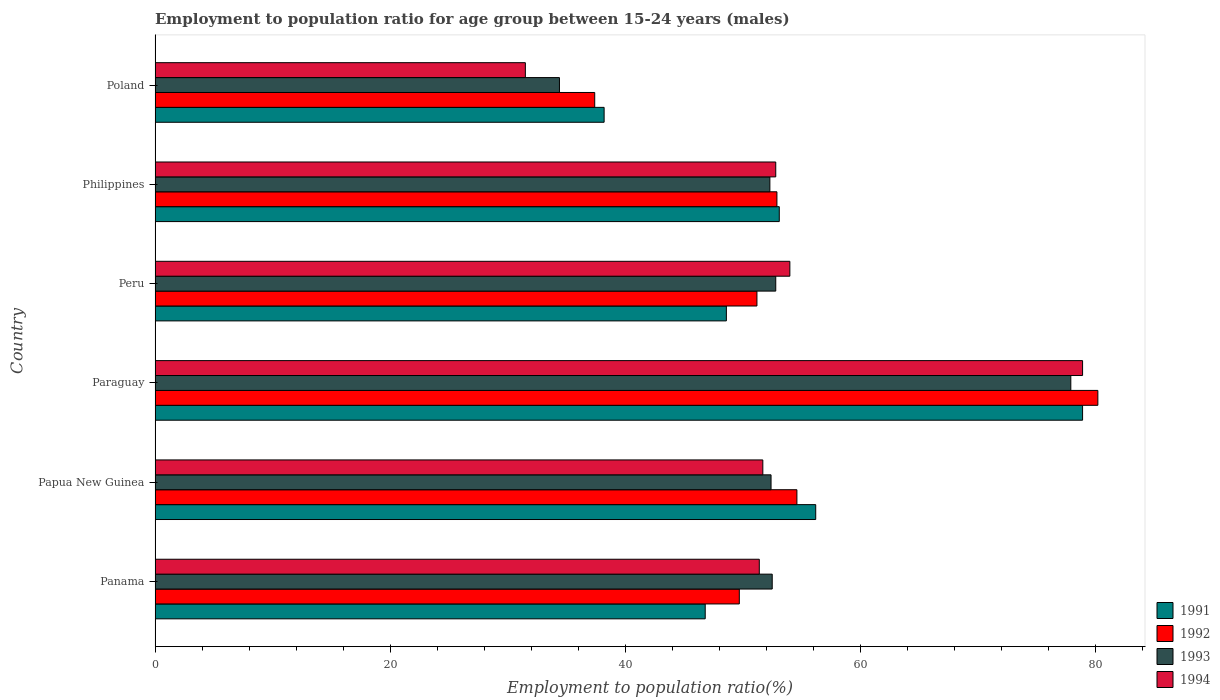How many different coloured bars are there?
Your answer should be compact. 4. How many groups of bars are there?
Provide a short and direct response. 6. Are the number of bars on each tick of the Y-axis equal?
Keep it short and to the point. Yes. What is the label of the 4th group of bars from the top?
Your response must be concise. Paraguay. What is the employment to population ratio in 1993 in Paraguay?
Ensure brevity in your answer.  77.9. Across all countries, what is the maximum employment to population ratio in 1992?
Ensure brevity in your answer.  80.2. Across all countries, what is the minimum employment to population ratio in 1993?
Ensure brevity in your answer.  34.4. In which country was the employment to population ratio in 1994 maximum?
Give a very brief answer. Paraguay. In which country was the employment to population ratio in 1994 minimum?
Ensure brevity in your answer.  Poland. What is the total employment to population ratio in 1991 in the graph?
Your answer should be very brief. 321.8. What is the difference between the employment to population ratio in 1993 in Papua New Guinea and that in Paraguay?
Your answer should be very brief. -25.5. What is the difference between the employment to population ratio in 1992 in Papua New Guinea and the employment to population ratio in 1991 in Panama?
Your answer should be very brief. 7.8. What is the average employment to population ratio in 1993 per country?
Your answer should be compact. 53.72. What is the difference between the employment to population ratio in 1993 and employment to population ratio in 1994 in Panama?
Make the answer very short. 1.1. What is the ratio of the employment to population ratio in 1993 in Panama to that in Poland?
Your answer should be compact. 1.53. Is the employment to population ratio in 1992 in Panama less than that in Papua New Guinea?
Give a very brief answer. Yes. Is the difference between the employment to population ratio in 1993 in Paraguay and Peru greater than the difference between the employment to population ratio in 1994 in Paraguay and Peru?
Your answer should be compact. Yes. What is the difference between the highest and the second highest employment to population ratio in 1992?
Give a very brief answer. 25.6. What is the difference between the highest and the lowest employment to population ratio in 1993?
Provide a succinct answer. 43.5. Is the sum of the employment to population ratio in 1991 in Panama and Philippines greater than the maximum employment to population ratio in 1993 across all countries?
Provide a short and direct response. Yes. Is it the case that in every country, the sum of the employment to population ratio in 1993 and employment to population ratio in 1992 is greater than the sum of employment to population ratio in 1991 and employment to population ratio in 1994?
Ensure brevity in your answer.  No. What does the 1st bar from the bottom in Peru represents?
Your response must be concise. 1991. How many countries are there in the graph?
Offer a terse response. 6. Does the graph contain any zero values?
Your answer should be very brief. No. Does the graph contain grids?
Your answer should be compact. No. Where does the legend appear in the graph?
Ensure brevity in your answer.  Bottom right. What is the title of the graph?
Your answer should be very brief. Employment to population ratio for age group between 15-24 years (males). What is the label or title of the X-axis?
Keep it short and to the point. Employment to population ratio(%). What is the label or title of the Y-axis?
Offer a very short reply. Country. What is the Employment to population ratio(%) of 1991 in Panama?
Offer a terse response. 46.8. What is the Employment to population ratio(%) of 1992 in Panama?
Keep it short and to the point. 49.7. What is the Employment to population ratio(%) of 1993 in Panama?
Ensure brevity in your answer.  52.5. What is the Employment to population ratio(%) in 1994 in Panama?
Provide a short and direct response. 51.4. What is the Employment to population ratio(%) in 1991 in Papua New Guinea?
Your response must be concise. 56.2. What is the Employment to population ratio(%) in 1992 in Papua New Guinea?
Offer a terse response. 54.6. What is the Employment to population ratio(%) in 1993 in Papua New Guinea?
Offer a very short reply. 52.4. What is the Employment to population ratio(%) in 1994 in Papua New Guinea?
Your response must be concise. 51.7. What is the Employment to population ratio(%) of 1991 in Paraguay?
Your answer should be compact. 78.9. What is the Employment to population ratio(%) of 1992 in Paraguay?
Ensure brevity in your answer.  80.2. What is the Employment to population ratio(%) in 1993 in Paraguay?
Keep it short and to the point. 77.9. What is the Employment to population ratio(%) of 1994 in Paraguay?
Your answer should be compact. 78.9. What is the Employment to population ratio(%) in 1991 in Peru?
Your answer should be compact. 48.6. What is the Employment to population ratio(%) of 1992 in Peru?
Offer a terse response. 51.2. What is the Employment to population ratio(%) in 1993 in Peru?
Your answer should be compact. 52.8. What is the Employment to population ratio(%) in 1994 in Peru?
Give a very brief answer. 54. What is the Employment to population ratio(%) of 1991 in Philippines?
Offer a very short reply. 53.1. What is the Employment to population ratio(%) in 1992 in Philippines?
Keep it short and to the point. 52.9. What is the Employment to population ratio(%) in 1993 in Philippines?
Keep it short and to the point. 52.3. What is the Employment to population ratio(%) of 1994 in Philippines?
Provide a short and direct response. 52.8. What is the Employment to population ratio(%) in 1991 in Poland?
Provide a short and direct response. 38.2. What is the Employment to population ratio(%) in 1992 in Poland?
Provide a succinct answer. 37.4. What is the Employment to population ratio(%) in 1993 in Poland?
Your response must be concise. 34.4. What is the Employment to population ratio(%) of 1994 in Poland?
Offer a very short reply. 31.5. Across all countries, what is the maximum Employment to population ratio(%) of 1991?
Provide a succinct answer. 78.9. Across all countries, what is the maximum Employment to population ratio(%) in 1992?
Keep it short and to the point. 80.2. Across all countries, what is the maximum Employment to population ratio(%) of 1993?
Keep it short and to the point. 77.9. Across all countries, what is the maximum Employment to population ratio(%) of 1994?
Your response must be concise. 78.9. Across all countries, what is the minimum Employment to population ratio(%) of 1991?
Your answer should be very brief. 38.2. Across all countries, what is the minimum Employment to population ratio(%) of 1992?
Provide a succinct answer. 37.4. Across all countries, what is the minimum Employment to population ratio(%) in 1993?
Provide a short and direct response. 34.4. Across all countries, what is the minimum Employment to population ratio(%) of 1994?
Your response must be concise. 31.5. What is the total Employment to population ratio(%) in 1991 in the graph?
Give a very brief answer. 321.8. What is the total Employment to population ratio(%) of 1992 in the graph?
Your response must be concise. 326. What is the total Employment to population ratio(%) of 1993 in the graph?
Keep it short and to the point. 322.3. What is the total Employment to population ratio(%) in 1994 in the graph?
Your response must be concise. 320.3. What is the difference between the Employment to population ratio(%) of 1992 in Panama and that in Papua New Guinea?
Provide a succinct answer. -4.9. What is the difference between the Employment to population ratio(%) of 1993 in Panama and that in Papua New Guinea?
Offer a very short reply. 0.1. What is the difference between the Employment to population ratio(%) in 1994 in Panama and that in Papua New Guinea?
Your answer should be compact. -0.3. What is the difference between the Employment to population ratio(%) in 1991 in Panama and that in Paraguay?
Make the answer very short. -32.1. What is the difference between the Employment to population ratio(%) of 1992 in Panama and that in Paraguay?
Your response must be concise. -30.5. What is the difference between the Employment to population ratio(%) of 1993 in Panama and that in Paraguay?
Give a very brief answer. -25.4. What is the difference between the Employment to population ratio(%) in 1994 in Panama and that in Paraguay?
Provide a short and direct response. -27.5. What is the difference between the Employment to population ratio(%) in 1992 in Panama and that in Peru?
Offer a terse response. -1.5. What is the difference between the Employment to population ratio(%) of 1991 in Panama and that in Philippines?
Provide a succinct answer. -6.3. What is the difference between the Employment to population ratio(%) in 1992 in Panama and that in Philippines?
Ensure brevity in your answer.  -3.2. What is the difference between the Employment to population ratio(%) of 1993 in Panama and that in Philippines?
Give a very brief answer. 0.2. What is the difference between the Employment to population ratio(%) of 1991 in Panama and that in Poland?
Your answer should be very brief. 8.6. What is the difference between the Employment to population ratio(%) of 1994 in Panama and that in Poland?
Provide a short and direct response. 19.9. What is the difference between the Employment to population ratio(%) of 1991 in Papua New Guinea and that in Paraguay?
Ensure brevity in your answer.  -22.7. What is the difference between the Employment to population ratio(%) of 1992 in Papua New Guinea and that in Paraguay?
Make the answer very short. -25.6. What is the difference between the Employment to population ratio(%) of 1993 in Papua New Guinea and that in Paraguay?
Your answer should be compact. -25.5. What is the difference between the Employment to population ratio(%) in 1994 in Papua New Guinea and that in Paraguay?
Give a very brief answer. -27.2. What is the difference between the Employment to population ratio(%) of 1994 in Papua New Guinea and that in Peru?
Give a very brief answer. -2.3. What is the difference between the Employment to population ratio(%) of 1991 in Papua New Guinea and that in Philippines?
Your answer should be very brief. 3.1. What is the difference between the Employment to population ratio(%) of 1993 in Papua New Guinea and that in Philippines?
Give a very brief answer. 0.1. What is the difference between the Employment to population ratio(%) of 1991 in Papua New Guinea and that in Poland?
Make the answer very short. 18. What is the difference between the Employment to population ratio(%) in 1992 in Papua New Guinea and that in Poland?
Provide a succinct answer. 17.2. What is the difference between the Employment to population ratio(%) of 1993 in Papua New Guinea and that in Poland?
Offer a very short reply. 18. What is the difference between the Employment to population ratio(%) in 1994 in Papua New Guinea and that in Poland?
Your answer should be very brief. 20.2. What is the difference between the Employment to population ratio(%) in 1991 in Paraguay and that in Peru?
Offer a very short reply. 30.3. What is the difference between the Employment to population ratio(%) in 1992 in Paraguay and that in Peru?
Ensure brevity in your answer.  29. What is the difference between the Employment to population ratio(%) of 1993 in Paraguay and that in Peru?
Offer a terse response. 25.1. What is the difference between the Employment to population ratio(%) of 1994 in Paraguay and that in Peru?
Provide a short and direct response. 24.9. What is the difference between the Employment to population ratio(%) in 1991 in Paraguay and that in Philippines?
Give a very brief answer. 25.8. What is the difference between the Employment to population ratio(%) in 1992 in Paraguay and that in Philippines?
Your answer should be very brief. 27.3. What is the difference between the Employment to population ratio(%) in 1993 in Paraguay and that in Philippines?
Your answer should be compact. 25.6. What is the difference between the Employment to population ratio(%) of 1994 in Paraguay and that in Philippines?
Offer a terse response. 26.1. What is the difference between the Employment to population ratio(%) of 1991 in Paraguay and that in Poland?
Your answer should be very brief. 40.7. What is the difference between the Employment to population ratio(%) of 1992 in Paraguay and that in Poland?
Make the answer very short. 42.8. What is the difference between the Employment to population ratio(%) of 1993 in Paraguay and that in Poland?
Ensure brevity in your answer.  43.5. What is the difference between the Employment to population ratio(%) of 1994 in Paraguay and that in Poland?
Your answer should be compact. 47.4. What is the difference between the Employment to population ratio(%) of 1992 in Peru and that in Philippines?
Offer a very short reply. -1.7. What is the difference between the Employment to population ratio(%) in 1991 in Peru and that in Poland?
Make the answer very short. 10.4. What is the difference between the Employment to population ratio(%) of 1992 in Philippines and that in Poland?
Provide a succinct answer. 15.5. What is the difference between the Employment to population ratio(%) of 1994 in Philippines and that in Poland?
Your answer should be very brief. 21.3. What is the difference between the Employment to population ratio(%) in 1992 in Panama and the Employment to population ratio(%) in 1993 in Papua New Guinea?
Keep it short and to the point. -2.7. What is the difference between the Employment to population ratio(%) in 1992 in Panama and the Employment to population ratio(%) in 1994 in Papua New Guinea?
Offer a terse response. -2. What is the difference between the Employment to population ratio(%) of 1993 in Panama and the Employment to population ratio(%) of 1994 in Papua New Guinea?
Offer a terse response. 0.8. What is the difference between the Employment to population ratio(%) of 1991 in Panama and the Employment to population ratio(%) of 1992 in Paraguay?
Give a very brief answer. -33.4. What is the difference between the Employment to population ratio(%) in 1991 in Panama and the Employment to population ratio(%) in 1993 in Paraguay?
Keep it short and to the point. -31.1. What is the difference between the Employment to population ratio(%) in 1991 in Panama and the Employment to population ratio(%) in 1994 in Paraguay?
Your answer should be compact. -32.1. What is the difference between the Employment to population ratio(%) of 1992 in Panama and the Employment to population ratio(%) of 1993 in Paraguay?
Ensure brevity in your answer.  -28.2. What is the difference between the Employment to population ratio(%) of 1992 in Panama and the Employment to population ratio(%) of 1994 in Paraguay?
Offer a very short reply. -29.2. What is the difference between the Employment to population ratio(%) of 1993 in Panama and the Employment to population ratio(%) of 1994 in Paraguay?
Provide a succinct answer. -26.4. What is the difference between the Employment to population ratio(%) of 1991 in Panama and the Employment to population ratio(%) of 1994 in Peru?
Offer a terse response. -7.2. What is the difference between the Employment to population ratio(%) in 1992 in Panama and the Employment to population ratio(%) in 1993 in Peru?
Provide a short and direct response. -3.1. What is the difference between the Employment to population ratio(%) of 1992 in Panama and the Employment to population ratio(%) of 1994 in Peru?
Your answer should be compact. -4.3. What is the difference between the Employment to population ratio(%) in 1993 in Panama and the Employment to population ratio(%) in 1994 in Peru?
Ensure brevity in your answer.  -1.5. What is the difference between the Employment to population ratio(%) in 1992 in Panama and the Employment to population ratio(%) in 1993 in Philippines?
Ensure brevity in your answer.  -2.6. What is the difference between the Employment to population ratio(%) in 1993 in Panama and the Employment to population ratio(%) in 1994 in Philippines?
Offer a very short reply. -0.3. What is the difference between the Employment to population ratio(%) of 1991 in Panama and the Employment to population ratio(%) of 1993 in Poland?
Keep it short and to the point. 12.4. What is the difference between the Employment to population ratio(%) in 1992 in Panama and the Employment to population ratio(%) in 1994 in Poland?
Provide a succinct answer. 18.2. What is the difference between the Employment to population ratio(%) of 1993 in Panama and the Employment to population ratio(%) of 1994 in Poland?
Your answer should be very brief. 21. What is the difference between the Employment to population ratio(%) of 1991 in Papua New Guinea and the Employment to population ratio(%) of 1993 in Paraguay?
Provide a short and direct response. -21.7. What is the difference between the Employment to population ratio(%) in 1991 in Papua New Guinea and the Employment to population ratio(%) in 1994 in Paraguay?
Offer a very short reply. -22.7. What is the difference between the Employment to population ratio(%) in 1992 in Papua New Guinea and the Employment to population ratio(%) in 1993 in Paraguay?
Give a very brief answer. -23.3. What is the difference between the Employment to population ratio(%) of 1992 in Papua New Guinea and the Employment to population ratio(%) of 1994 in Paraguay?
Offer a very short reply. -24.3. What is the difference between the Employment to population ratio(%) of 1993 in Papua New Guinea and the Employment to population ratio(%) of 1994 in Paraguay?
Your response must be concise. -26.5. What is the difference between the Employment to population ratio(%) of 1991 in Papua New Guinea and the Employment to population ratio(%) of 1992 in Peru?
Provide a short and direct response. 5. What is the difference between the Employment to population ratio(%) of 1991 in Papua New Guinea and the Employment to population ratio(%) of 1994 in Peru?
Your answer should be compact. 2.2. What is the difference between the Employment to population ratio(%) of 1992 in Papua New Guinea and the Employment to population ratio(%) of 1993 in Peru?
Make the answer very short. 1.8. What is the difference between the Employment to population ratio(%) in 1991 in Papua New Guinea and the Employment to population ratio(%) in 1993 in Poland?
Your answer should be very brief. 21.8. What is the difference between the Employment to population ratio(%) of 1991 in Papua New Guinea and the Employment to population ratio(%) of 1994 in Poland?
Your answer should be compact. 24.7. What is the difference between the Employment to population ratio(%) in 1992 in Papua New Guinea and the Employment to population ratio(%) in 1993 in Poland?
Keep it short and to the point. 20.2. What is the difference between the Employment to population ratio(%) of 1992 in Papua New Guinea and the Employment to population ratio(%) of 1994 in Poland?
Give a very brief answer. 23.1. What is the difference between the Employment to population ratio(%) in 1993 in Papua New Guinea and the Employment to population ratio(%) in 1994 in Poland?
Give a very brief answer. 20.9. What is the difference between the Employment to population ratio(%) of 1991 in Paraguay and the Employment to population ratio(%) of 1992 in Peru?
Your answer should be compact. 27.7. What is the difference between the Employment to population ratio(%) of 1991 in Paraguay and the Employment to population ratio(%) of 1993 in Peru?
Keep it short and to the point. 26.1. What is the difference between the Employment to population ratio(%) of 1991 in Paraguay and the Employment to population ratio(%) of 1994 in Peru?
Provide a short and direct response. 24.9. What is the difference between the Employment to population ratio(%) in 1992 in Paraguay and the Employment to population ratio(%) in 1993 in Peru?
Your answer should be very brief. 27.4. What is the difference between the Employment to population ratio(%) of 1992 in Paraguay and the Employment to population ratio(%) of 1994 in Peru?
Your answer should be compact. 26.2. What is the difference between the Employment to population ratio(%) in 1993 in Paraguay and the Employment to population ratio(%) in 1994 in Peru?
Offer a terse response. 23.9. What is the difference between the Employment to population ratio(%) of 1991 in Paraguay and the Employment to population ratio(%) of 1992 in Philippines?
Offer a very short reply. 26. What is the difference between the Employment to population ratio(%) of 1991 in Paraguay and the Employment to population ratio(%) of 1993 in Philippines?
Your response must be concise. 26.6. What is the difference between the Employment to population ratio(%) of 1991 in Paraguay and the Employment to population ratio(%) of 1994 in Philippines?
Offer a very short reply. 26.1. What is the difference between the Employment to population ratio(%) of 1992 in Paraguay and the Employment to population ratio(%) of 1993 in Philippines?
Offer a very short reply. 27.9. What is the difference between the Employment to population ratio(%) in 1992 in Paraguay and the Employment to population ratio(%) in 1994 in Philippines?
Provide a succinct answer. 27.4. What is the difference between the Employment to population ratio(%) of 1993 in Paraguay and the Employment to population ratio(%) of 1994 in Philippines?
Give a very brief answer. 25.1. What is the difference between the Employment to population ratio(%) in 1991 in Paraguay and the Employment to population ratio(%) in 1992 in Poland?
Ensure brevity in your answer.  41.5. What is the difference between the Employment to population ratio(%) in 1991 in Paraguay and the Employment to population ratio(%) in 1993 in Poland?
Provide a succinct answer. 44.5. What is the difference between the Employment to population ratio(%) of 1991 in Paraguay and the Employment to population ratio(%) of 1994 in Poland?
Provide a succinct answer. 47.4. What is the difference between the Employment to population ratio(%) in 1992 in Paraguay and the Employment to population ratio(%) in 1993 in Poland?
Offer a very short reply. 45.8. What is the difference between the Employment to population ratio(%) of 1992 in Paraguay and the Employment to population ratio(%) of 1994 in Poland?
Your answer should be very brief. 48.7. What is the difference between the Employment to population ratio(%) of 1993 in Paraguay and the Employment to population ratio(%) of 1994 in Poland?
Make the answer very short. 46.4. What is the difference between the Employment to population ratio(%) in 1991 in Peru and the Employment to population ratio(%) in 1992 in Philippines?
Offer a very short reply. -4.3. What is the difference between the Employment to population ratio(%) of 1991 in Peru and the Employment to population ratio(%) of 1993 in Philippines?
Make the answer very short. -3.7. What is the difference between the Employment to population ratio(%) of 1992 in Peru and the Employment to population ratio(%) of 1994 in Philippines?
Ensure brevity in your answer.  -1.6. What is the difference between the Employment to population ratio(%) in 1993 in Peru and the Employment to population ratio(%) in 1994 in Philippines?
Keep it short and to the point. 0. What is the difference between the Employment to population ratio(%) of 1991 in Peru and the Employment to population ratio(%) of 1994 in Poland?
Your answer should be compact. 17.1. What is the difference between the Employment to population ratio(%) in 1992 in Peru and the Employment to population ratio(%) in 1994 in Poland?
Offer a very short reply. 19.7. What is the difference between the Employment to population ratio(%) of 1993 in Peru and the Employment to population ratio(%) of 1994 in Poland?
Your answer should be compact. 21.3. What is the difference between the Employment to population ratio(%) of 1991 in Philippines and the Employment to population ratio(%) of 1992 in Poland?
Ensure brevity in your answer.  15.7. What is the difference between the Employment to population ratio(%) of 1991 in Philippines and the Employment to population ratio(%) of 1993 in Poland?
Provide a succinct answer. 18.7. What is the difference between the Employment to population ratio(%) in 1991 in Philippines and the Employment to population ratio(%) in 1994 in Poland?
Your answer should be very brief. 21.6. What is the difference between the Employment to population ratio(%) in 1992 in Philippines and the Employment to population ratio(%) in 1994 in Poland?
Ensure brevity in your answer.  21.4. What is the difference between the Employment to population ratio(%) in 1993 in Philippines and the Employment to population ratio(%) in 1994 in Poland?
Keep it short and to the point. 20.8. What is the average Employment to population ratio(%) of 1991 per country?
Ensure brevity in your answer.  53.63. What is the average Employment to population ratio(%) of 1992 per country?
Make the answer very short. 54.33. What is the average Employment to population ratio(%) of 1993 per country?
Offer a terse response. 53.72. What is the average Employment to population ratio(%) of 1994 per country?
Give a very brief answer. 53.38. What is the difference between the Employment to population ratio(%) in 1991 and Employment to population ratio(%) in 1993 in Panama?
Your answer should be very brief. -5.7. What is the difference between the Employment to population ratio(%) in 1991 and Employment to population ratio(%) in 1994 in Panama?
Ensure brevity in your answer.  -4.6. What is the difference between the Employment to population ratio(%) of 1992 and Employment to population ratio(%) of 1993 in Panama?
Offer a very short reply. -2.8. What is the difference between the Employment to population ratio(%) of 1992 and Employment to population ratio(%) of 1994 in Panama?
Offer a very short reply. -1.7. What is the difference between the Employment to population ratio(%) in 1991 and Employment to population ratio(%) in 1993 in Papua New Guinea?
Provide a short and direct response. 3.8. What is the difference between the Employment to population ratio(%) in 1991 and Employment to population ratio(%) in 1994 in Papua New Guinea?
Your response must be concise. 4.5. What is the difference between the Employment to population ratio(%) of 1991 and Employment to population ratio(%) of 1992 in Paraguay?
Your answer should be compact. -1.3. What is the difference between the Employment to population ratio(%) in 1991 and Employment to population ratio(%) in 1993 in Paraguay?
Provide a succinct answer. 1. What is the difference between the Employment to population ratio(%) in 1992 and Employment to population ratio(%) in 1993 in Paraguay?
Give a very brief answer. 2.3. What is the difference between the Employment to population ratio(%) in 1992 and Employment to population ratio(%) in 1993 in Peru?
Offer a terse response. -1.6. What is the difference between the Employment to population ratio(%) in 1993 and Employment to population ratio(%) in 1994 in Peru?
Make the answer very short. -1.2. What is the difference between the Employment to population ratio(%) in 1991 and Employment to population ratio(%) in 1992 in Philippines?
Keep it short and to the point. 0.2. What is the difference between the Employment to population ratio(%) in 1992 and Employment to population ratio(%) in 1993 in Philippines?
Provide a succinct answer. 0.6. What is the difference between the Employment to population ratio(%) of 1992 and Employment to population ratio(%) of 1994 in Philippines?
Your response must be concise. 0.1. What is the difference between the Employment to population ratio(%) in 1993 and Employment to population ratio(%) in 1994 in Philippines?
Your answer should be very brief. -0.5. What is the difference between the Employment to population ratio(%) in 1991 and Employment to population ratio(%) in 1992 in Poland?
Provide a short and direct response. 0.8. What is the difference between the Employment to population ratio(%) of 1991 and Employment to population ratio(%) of 1993 in Poland?
Your answer should be compact. 3.8. What is the difference between the Employment to population ratio(%) of 1991 and Employment to population ratio(%) of 1994 in Poland?
Keep it short and to the point. 6.7. What is the difference between the Employment to population ratio(%) of 1992 and Employment to population ratio(%) of 1993 in Poland?
Your answer should be compact. 3. What is the ratio of the Employment to population ratio(%) of 1991 in Panama to that in Papua New Guinea?
Keep it short and to the point. 0.83. What is the ratio of the Employment to population ratio(%) of 1992 in Panama to that in Papua New Guinea?
Ensure brevity in your answer.  0.91. What is the ratio of the Employment to population ratio(%) of 1994 in Panama to that in Papua New Guinea?
Your response must be concise. 0.99. What is the ratio of the Employment to population ratio(%) of 1991 in Panama to that in Paraguay?
Ensure brevity in your answer.  0.59. What is the ratio of the Employment to population ratio(%) in 1992 in Panama to that in Paraguay?
Your answer should be very brief. 0.62. What is the ratio of the Employment to population ratio(%) of 1993 in Panama to that in Paraguay?
Offer a terse response. 0.67. What is the ratio of the Employment to population ratio(%) of 1994 in Panama to that in Paraguay?
Give a very brief answer. 0.65. What is the ratio of the Employment to population ratio(%) of 1992 in Panama to that in Peru?
Make the answer very short. 0.97. What is the ratio of the Employment to population ratio(%) of 1993 in Panama to that in Peru?
Make the answer very short. 0.99. What is the ratio of the Employment to population ratio(%) in 1994 in Panama to that in Peru?
Offer a very short reply. 0.95. What is the ratio of the Employment to population ratio(%) of 1991 in Panama to that in Philippines?
Keep it short and to the point. 0.88. What is the ratio of the Employment to population ratio(%) in 1992 in Panama to that in Philippines?
Ensure brevity in your answer.  0.94. What is the ratio of the Employment to population ratio(%) in 1993 in Panama to that in Philippines?
Provide a succinct answer. 1. What is the ratio of the Employment to population ratio(%) in 1994 in Panama to that in Philippines?
Provide a succinct answer. 0.97. What is the ratio of the Employment to population ratio(%) in 1991 in Panama to that in Poland?
Your answer should be very brief. 1.23. What is the ratio of the Employment to population ratio(%) in 1992 in Panama to that in Poland?
Provide a succinct answer. 1.33. What is the ratio of the Employment to population ratio(%) in 1993 in Panama to that in Poland?
Offer a very short reply. 1.53. What is the ratio of the Employment to population ratio(%) of 1994 in Panama to that in Poland?
Offer a terse response. 1.63. What is the ratio of the Employment to population ratio(%) of 1991 in Papua New Guinea to that in Paraguay?
Keep it short and to the point. 0.71. What is the ratio of the Employment to population ratio(%) of 1992 in Papua New Guinea to that in Paraguay?
Offer a terse response. 0.68. What is the ratio of the Employment to population ratio(%) in 1993 in Papua New Guinea to that in Paraguay?
Give a very brief answer. 0.67. What is the ratio of the Employment to population ratio(%) in 1994 in Papua New Guinea to that in Paraguay?
Keep it short and to the point. 0.66. What is the ratio of the Employment to population ratio(%) of 1991 in Papua New Guinea to that in Peru?
Your answer should be very brief. 1.16. What is the ratio of the Employment to population ratio(%) in 1992 in Papua New Guinea to that in Peru?
Your answer should be compact. 1.07. What is the ratio of the Employment to population ratio(%) in 1994 in Papua New Guinea to that in Peru?
Keep it short and to the point. 0.96. What is the ratio of the Employment to population ratio(%) in 1991 in Papua New Guinea to that in Philippines?
Your response must be concise. 1.06. What is the ratio of the Employment to population ratio(%) of 1992 in Papua New Guinea to that in Philippines?
Offer a terse response. 1.03. What is the ratio of the Employment to population ratio(%) in 1994 in Papua New Guinea to that in Philippines?
Give a very brief answer. 0.98. What is the ratio of the Employment to population ratio(%) in 1991 in Papua New Guinea to that in Poland?
Provide a short and direct response. 1.47. What is the ratio of the Employment to population ratio(%) in 1992 in Papua New Guinea to that in Poland?
Keep it short and to the point. 1.46. What is the ratio of the Employment to population ratio(%) in 1993 in Papua New Guinea to that in Poland?
Offer a terse response. 1.52. What is the ratio of the Employment to population ratio(%) in 1994 in Papua New Guinea to that in Poland?
Your response must be concise. 1.64. What is the ratio of the Employment to population ratio(%) in 1991 in Paraguay to that in Peru?
Your answer should be compact. 1.62. What is the ratio of the Employment to population ratio(%) of 1992 in Paraguay to that in Peru?
Ensure brevity in your answer.  1.57. What is the ratio of the Employment to population ratio(%) of 1993 in Paraguay to that in Peru?
Your answer should be compact. 1.48. What is the ratio of the Employment to population ratio(%) in 1994 in Paraguay to that in Peru?
Your response must be concise. 1.46. What is the ratio of the Employment to population ratio(%) of 1991 in Paraguay to that in Philippines?
Your answer should be compact. 1.49. What is the ratio of the Employment to population ratio(%) in 1992 in Paraguay to that in Philippines?
Provide a succinct answer. 1.52. What is the ratio of the Employment to population ratio(%) in 1993 in Paraguay to that in Philippines?
Provide a succinct answer. 1.49. What is the ratio of the Employment to population ratio(%) in 1994 in Paraguay to that in Philippines?
Give a very brief answer. 1.49. What is the ratio of the Employment to population ratio(%) of 1991 in Paraguay to that in Poland?
Make the answer very short. 2.07. What is the ratio of the Employment to population ratio(%) of 1992 in Paraguay to that in Poland?
Make the answer very short. 2.14. What is the ratio of the Employment to population ratio(%) in 1993 in Paraguay to that in Poland?
Offer a very short reply. 2.26. What is the ratio of the Employment to population ratio(%) of 1994 in Paraguay to that in Poland?
Your answer should be very brief. 2.5. What is the ratio of the Employment to population ratio(%) in 1991 in Peru to that in Philippines?
Your response must be concise. 0.92. What is the ratio of the Employment to population ratio(%) of 1992 in Peru to that in Philippines?
Provide a short and direct response. 0.97. What is the ratio of the Employment to population ratio(%) of 1993 in Peru to that in Philippines?
Your response must be concise. 1.01. What is the ratio of the Employment to population ratio(%) of 1994 in Peru to that in Philippines?
Give a very brief answer. 1.02. What is the ratio of the Employment to population ratio(%) in 1991 in Peru to that in Poland?
Offer a terse response. 1.27. What is the ratio of the Employment to population ratio(%) of 1992 in Peru to that in Poland?
Give a very brief answer. 1.37. What is the ratio of the Employment to population ratio(%) in 1993 in Peru to that in Poland?
Provide a short and direct response. 1.53. What is the ratio of the Employment to population ratio(%) in 1994 in Peru to that in Poland?
Give a very brief answer. 1.71. What is the ratio of the Employment to population ratio(%) of 1991 in Philippines to that in Poland?
Keep it short and to the point. 1.39. What is the ratio of the Employment to population ratio(%) in 1992 in Philippines to that in Poland?
Make the answer very short. 1.41. What is the ratio of the Employment to population ratio(%) in 1993 in Philippines to that in Poland?
Give a very brief answer. 1.52. What is the ratio of the Employment to population ratio(%) of 1994 in Philippines to that in Poland?
Offer a terse response. 1.68. What is the difference between the highest and the second highest Employment to population ratio(%) in 1991?
Your answer should be very brief. 22.7. What is the difference between the highest and the second highest Employment to population ratio(%) of 1992?
Ensure brevity in your answer.  25.6. What is the difference between the highest and the second highest Employment to population ratio(%) in 1993?
Your answer should be very brief. 25.1. What is the difference between the highest and the second highest Employment to population ratio(%) of 1994?
Keep it short and to the point. 24.9. What is the difference between the highest and the lowest Employment to population ratio(%) in 1991?
Offer a very short reply. 40.7. What is the difference between the highest and the lowest Employment to population ratio(%) of 1992?
Your answer should be compact. 42.8. What is the difference between the highest and the lowest Employment to population ratio(%) of 1993?
Your answer should be compact. 43.5. What is the difference between the highest and the lowest Employment to population ratio(%) of 1994?
Provide a succinct answer. 47.4. 